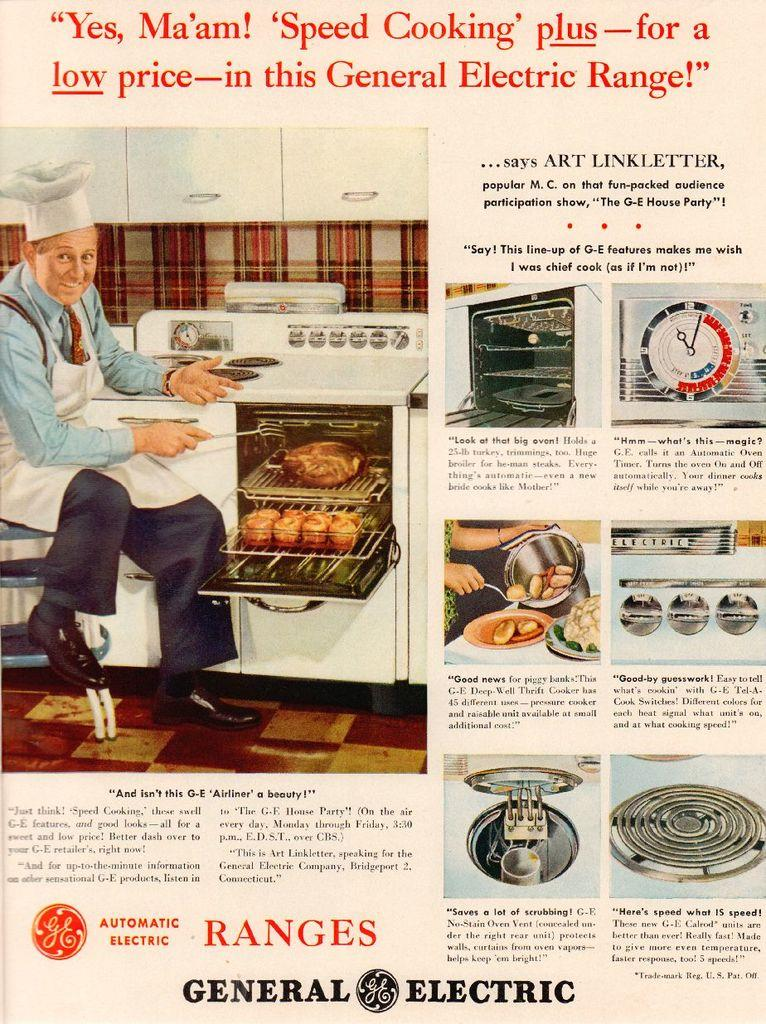<image>
Render a clear and concise summary of the photo. An old General Electric advertisement shows a man in a chef's hat. 